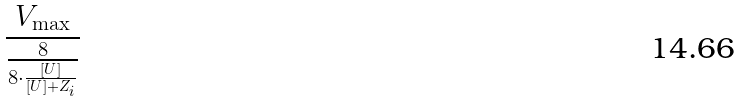<formula> <loc_0><loc_0><loc_500><loc_500>\frac { V _ { \max } } { \frac { 8 } { 8 \cdot \frac { [ U ] } { [ U ] + Z _ { i } } } }</formula> 